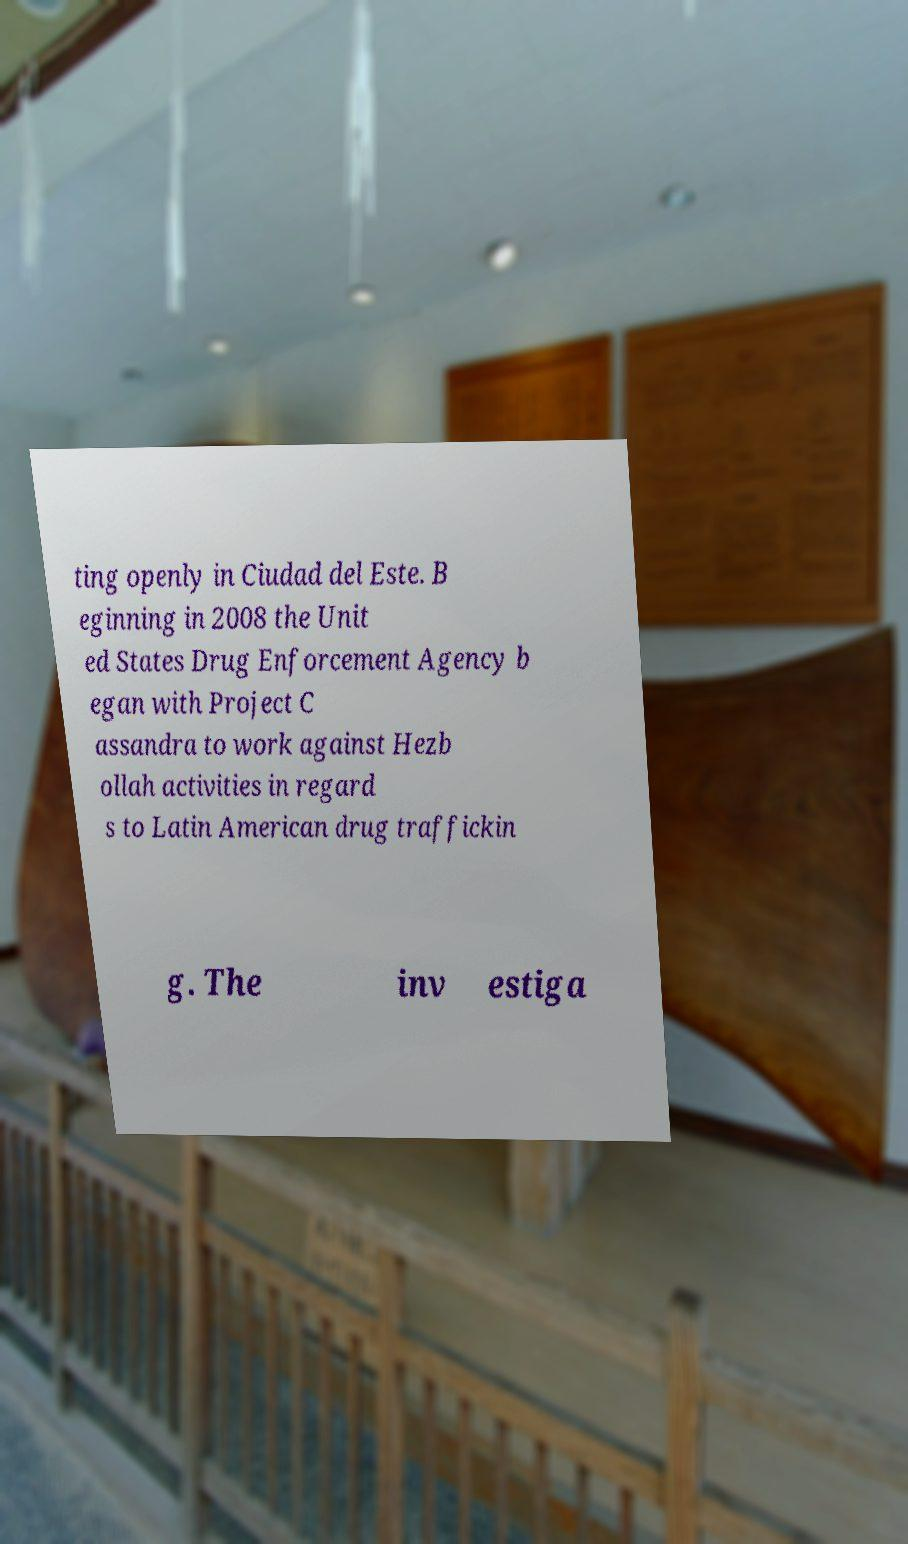Can you read and provide the text displayed in the image?This photo seems to have some interesting text. Can you extract and type it out for me? ting openly in Ciudad del Este. B eginning in 2008 the Unit ed States Drug Enforcement Agency b egan with Project C assandra to work against Hezb ollah activities in regard s to Latin American drug traffickin g. The inv estiga 